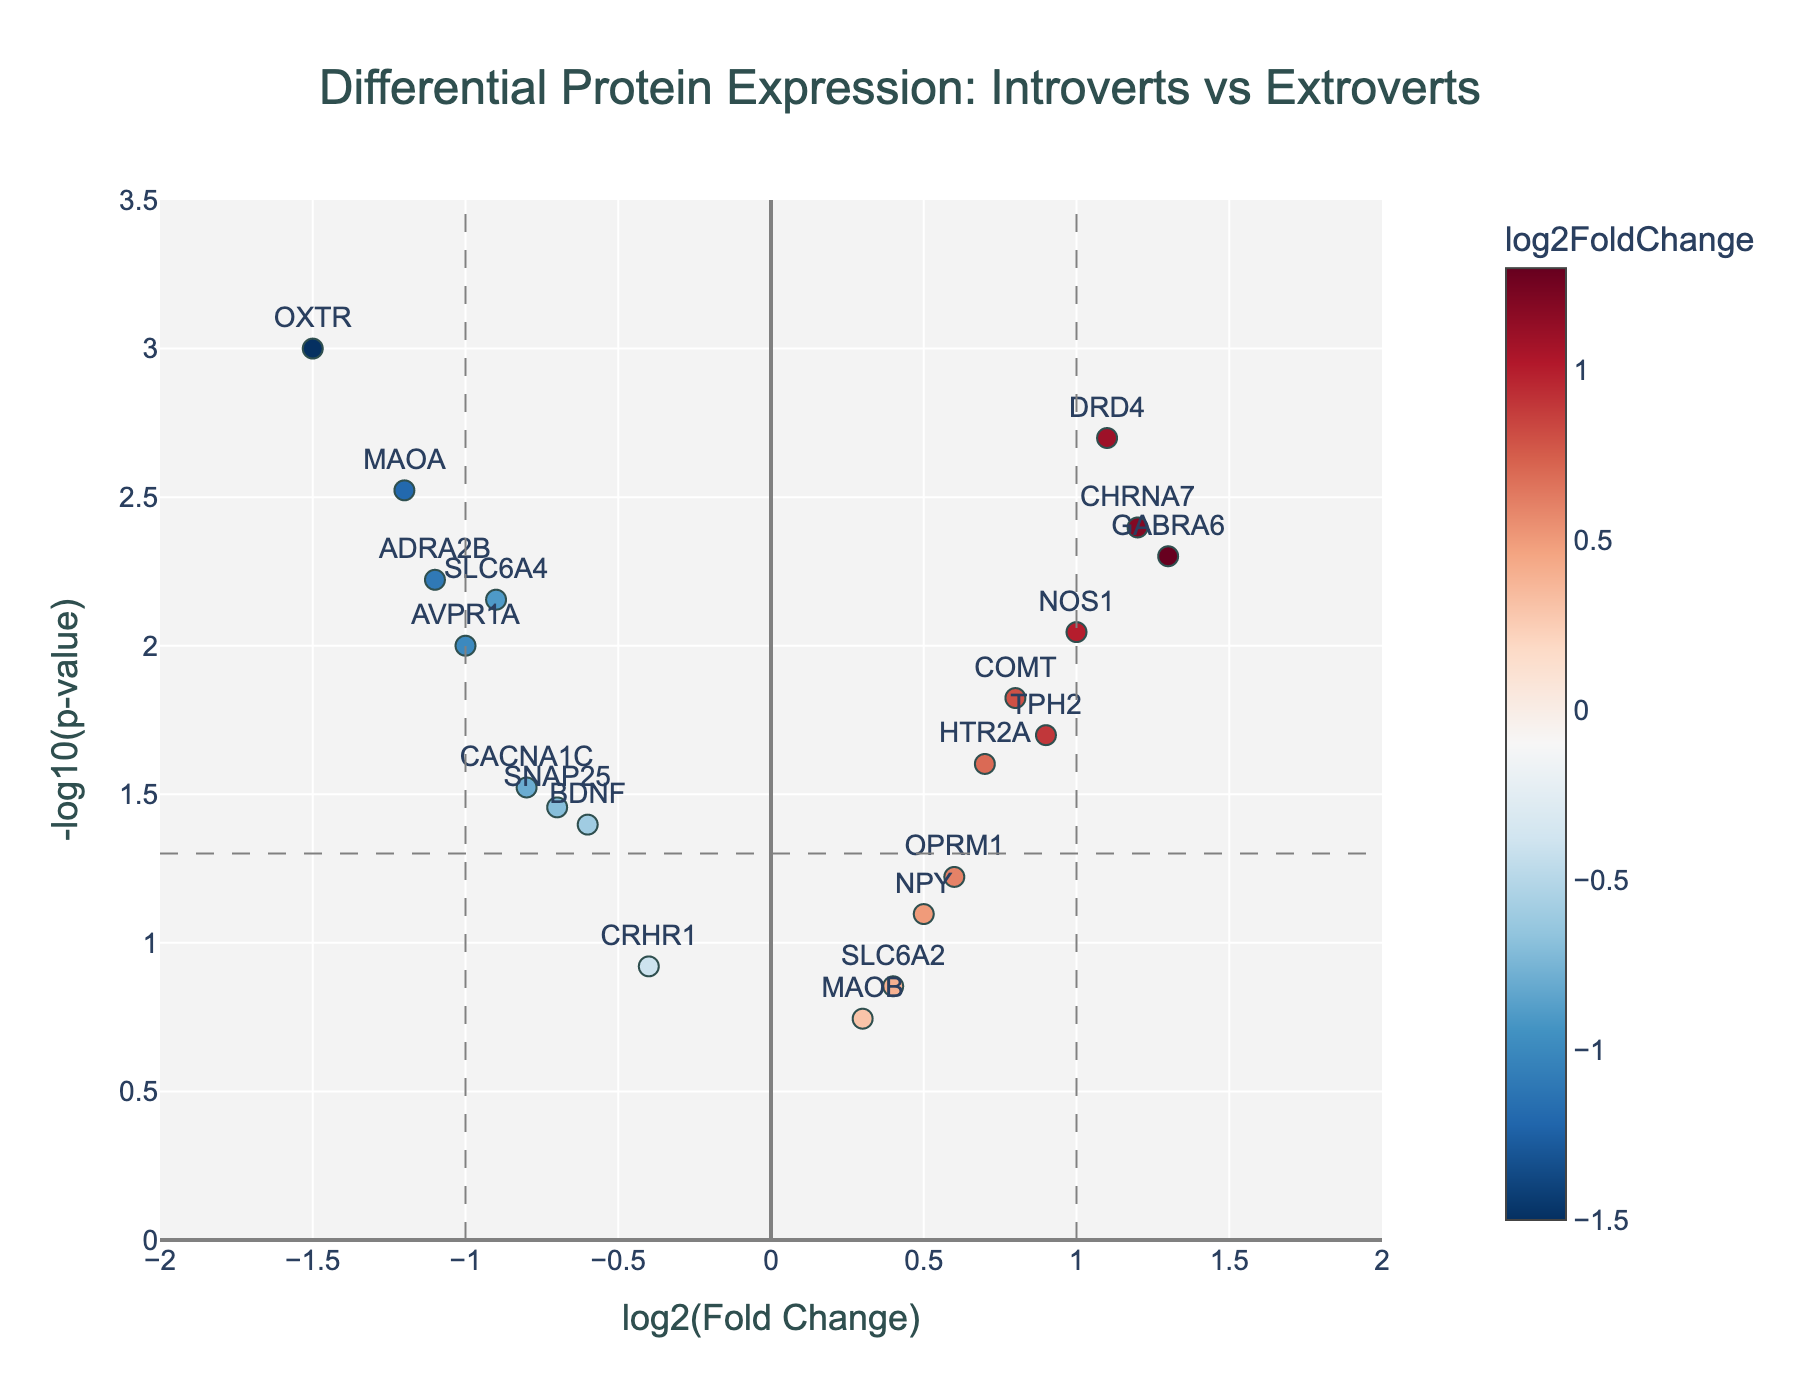what is the title of the figure? The title is usually the largest or most prominently displayed text at the top of the figure. For this plot, it is centrally aligned above the data.
Answer: Differential Protein Expression: Introverts vs Extroverts How many proteins have a log2FoldChange greater than 1? Look for data points to the right of the vertical line at x = 1. These proteins have a log2FoldChange greater than 1.
Answer: 3 Which protein has the smallest p-value? Identify the protein with the highest -log10(p-value) on the y-axis, as the higher it is, the smaller the original p-value.
Answer: OXTR Which protein has the greatest log2FoldChange among introverts? To determine this, look for the protein with the most negative log2FoldChange value, indicating the greatest decrease, since introverts are considered the baseline (negative log2FC).
Answer: OXTR What is the log2FoldChange threshold for labeling significant proteins? The plot has vertical dashed lines, and the threshold for significant log2FoldChange is where these lines are placed.
Answer: ±1 Which protein shows the least evidence against the null hypothesis? Look for the protein with the lowest -log10(p-value) on the y-axis; the lower this value, the less evidence against the null hypothesis.
Answer: MAOB What is the fold change of protein GABRA6 and is it considered significant? GABRA6 is labeled on the plot. Check its position relative to both the horizontal and vertical dashed lines for its statistical and biological significance.
Answer: 1.3, Yes Which two proteins have log2FoldChanges between -0.5 and -1.0, and are they statistically significant? Find data points within the specified range of log2FoldChange, and check their corresponding p-values.
Answer: CACNA1C and SNAP25; Yes For proteins with a p-value less than 0.01, which has the smallest effect size? Locate all proteins with -log10(p-value) > 2. Then, find the one with a log2FoldChange closest to zero.
Answer: COMT How many proteins are not statistically significant (p-value >= 0.05)? Look at the horizontal dashed line; count the proteins below this line indicating their p-values are above 0.05.
Answer: 4 